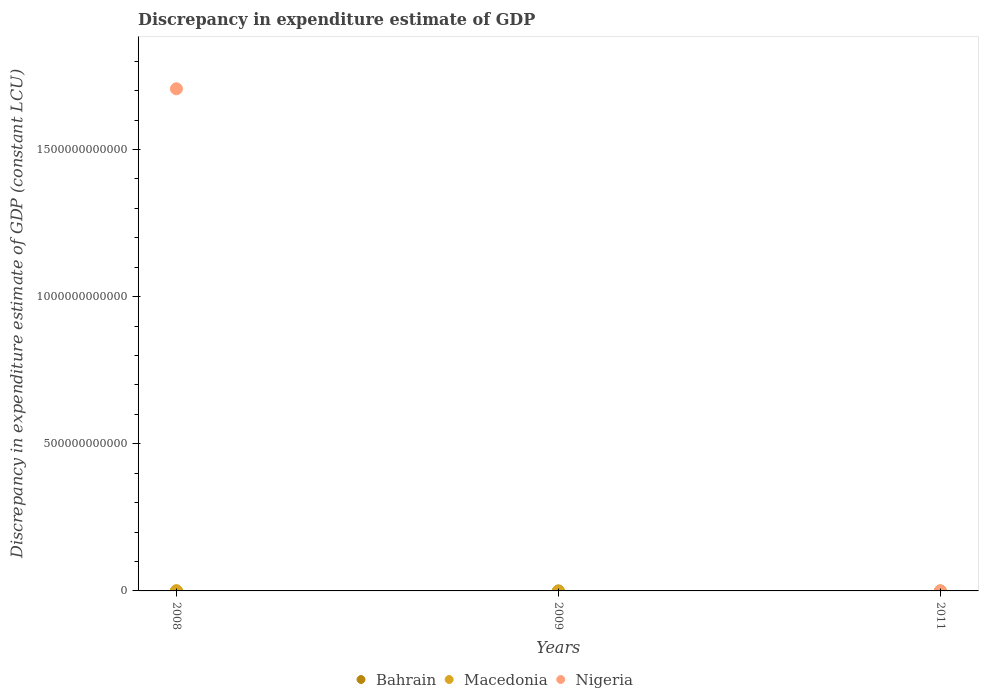Is the number of dotlines equal to the number of legend labels?
Offer a terse response. No. What is the discrepancy in expenditure estimate of GDP in Nigeria in 2008?
Your answer should be compact. 1.71e+12. Across all years, what is the maximum discrepancy in expenditure estimate of GDP in Macedonia?
Offer a very short reply. 4.12e+08. Across all years, what is the minimum discrepancy in expenditure estimate of GDP in Bahrain?
Ensure brevity in your answer.  5.00e+04. What is the total discrepancy in expenditure estimate of GDP in Nigeria in the graph?
Provide a succinct answer. 1.71e+12. What is the difference between the discrepancy in expenditure estimate of GDP in Bahrain in 2008 and that in 2011?
Your response must be concise. 7.80e+05. What is the difference between the discrepancy in expenditure estimate of GDP in Nigeria in 2011 and the discrepancy in expenditure estimate of GDP in Bahrain in 2008?
Make the answer very short. -8.30e+05. What is the average discrepancy in expenditure estimate of GDP in Macedonia per year?
Offer a very short reply. 1.37e+08. In the year 2008, what is the difference between the discrepancy in expenditure estimate of GDP in Bahrain and discrepancy in expenditure estimate of GDP in Macedonia?
Offer a terse response. -4.11e+08. In how many years, is the discrepancy in expenditure estimate of GDP in Nigeria greater than 300000000000 LCU?
Provide a short and direct response. 1. What is the difference between the highest and the lowest discrepancy in expenditure estimate of GDP in Macedonia?
Ensure brevity in your answer.  4.12e+08. Is it the case that in every year, the sum of the discrepancy in expenditure estimate of GDP in Macedonia and discrepancy in expenditure estimate of GDP in Nigeria  is greater than the discrepancy in expenditure estimate of GDP in Bahrain?
Give a very brief answer. No. Does the discrepancy in expenditure estimate of GDP in Nigeria monotonically increase over the years?
Your response must be concise. No. How many dotlines are there?
Provide a short and direct response. 3. How many years are there in the graph?
Keep it short and to the point. 3. What is the difference between two consecutive major ticks on the Y-axis?
Offer a very short reply. 5.00e+11. Are the values on the major ticks of Y-axis written in scientific E-notation?
Your answer should be compact. No. Does the graph contain grids?
Ensure brevity in your answer.  No. Where does the legend appear in the graph?
Give a very brief answer. Bottom center. How many legend labels are there?
Ensure brevity in your answer.  3. What is the title of the graph?
Keep it short and to the point. Discrepancy in expenditure estimate of GDP. Does "Central Europe" appear as one of the legend labels in the graph?
Give a very brief answer. No. What is the label or title of the Y-axis?
Your response must be concise. Discrepancy in expenditure estimate of GDP (constant LCU). What is the Discrepancy in expenditure estimate of GDP (constant LCU) of Bahrain in 2008?
Your answer should be very brief. 8.30e+05. What is the Discrepancy in expenditure estimate of GDP (constant LCU) in Macedonia in 2008?
Make the answer very short. 4.12e+08. What is the Discrepancy in expenditure estimate of GDP (constant LCU) of Nigeria in 2008?
Your answer should be compact. 1.71e+12. What is the Discrepancy in expenditure estimate of GDP (constant LCU) in Bahrain in 2009?
Offer a very short reply. 3.50e+05. What is the Discrepancy in expenditure estimate of GDP (constant LCU) in Macedonia in 2009?
Provide a succinct answer. 0. Across all years, what is the maximum Discrepancy in expenditure estimate of GDP (constant LCU) of Bahrain?
Provide a short and direct response. 8.30e+05. Across all years, what is the maximum Discrepancy in expenditure estimate of GDP (constant LCU) of Macedonia?
Keep it short and to the point. 4.12e+08. Across all years, what is the maximum Discrepancy in expenditure estimate of GDP (constant LCU) in Nigeria?
Give a very brief answer. 1.71e+12. Across all years, what is the minimum Discrepancy in expenditure estimate of GDP (constant LCU) in Bahrain?
Provide a short and direct response. 5.00e+04. What is the total Discrepancy in expenditure estimate of GDP (constant LCU) in Bahrain in the graph?
Give a very brief answer. 1.23e+06. What is the total Discrepancy in expenditure estimate of GDP (constant LCU) in Macedonia in the graph?
Offer a terse response. 4.12e+08. What is the total Discrepancy in expenditure estimate of GDP (constant LCU) of Nigeria in the graph?
Offer a very short reply. 1.71e+12. What is the difference between the Discrepancy in expenditure estimate of GDP (constant LCU) in Bahrain in 2008 and that in 2009?
Your answer should be very brief. 4.80e+05. What is the difference between the Discrepancy in expenditure estimate of GDP (constant LCU) of Bahrain in 2008 and that in 2011?
Your response must be concise. 7.80e+05. What is the difference between the Discrepancy in expenditure estimate of GDP (constant LCU) of Bahrain in 2009 and that in 2011?
Your answer should be compact. 3.00e+05. What is the average Discrepancy in expenditure estimate of GDP (constant LCU) in Bahrain per year?
Your response must be concise. 4.10e+05. What is the average Discrepancy in expenditure estimate of GDP (constant LCU) in Macedonia per year?
Your answer should be compact. 1.37e+08. What is the average Discrepancy in expenditure estimate of GDP (constant LCU) in Nigeria per year?
Your answer should be very brief. 5.69e+11. In the year 2008, what is the difference between the Discrepancy in expenditure estimate of GDP (constant LCU) of Bahrain and Discrepancy in expenditure estimate of GDP (constant LCU) of Macedonia?
Make the answer very short. -4.11e+08. In the year 2008, what is the difference between the Discrepancy in expenditure estimate of GDP (constant LCU) of Bahrain and Discrepancy in expenditure estimate of GDP (constant LCU) of Nigeria?
Provide a short and direct response. -1.71e+12. In the year 2008, what is the difference between the Discrepancy in expenditure estimate of GDP (constant LCU) in Macedonia and Discrepancy in expenditure estimate of GDP (constant LCU) in Nigeria?
Provide a succinct answer. -1.71e+12. What is the ratio of the Discrepancy in expenditure estimate of GDP (constant LCU) in Bahrain in 2008 to that in 2009?
Your answer should be very brief. 2.37. What is the ratio of the Discrepancy in expenditure estimate of GDP (constant LCU) of Bahrain in 2008 to that in 2011?
Offer a very short reply. 16.6. What is the difference between the highest and the second highest Discrepancy in expenditure estimate of GDP (constant LCU) in Bahrain?
Your response must be concise. 4.80e+05. What is the difference between the highest and the lowest Discrepancy in expenditure estimate of GDP (constant LCU) in Bahrain?
Your response must be concise. 7.80e+05. What is the difference between the highest and the lowest Discrepancy in expenditure estimate of GDP (constant LCU) in Macedonia?
Your answer should be very brief. 4.12e+08. What is the difference between the highest and the lowest Discrepancy in expenditure estimate of GDP (constant LCU) in Nigeria?
Your response must be concise. 1.71e+12. 